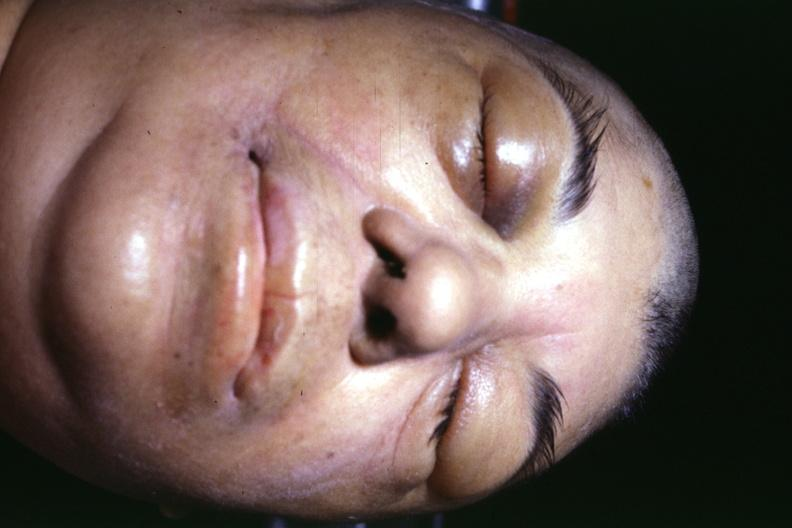why does this image show jaundice due to terminal alcoholic cirrhosis with shock and typical facial appearance of edema?
Answer the question using a single word or phrase. Due generalized capillary permeability increase or 